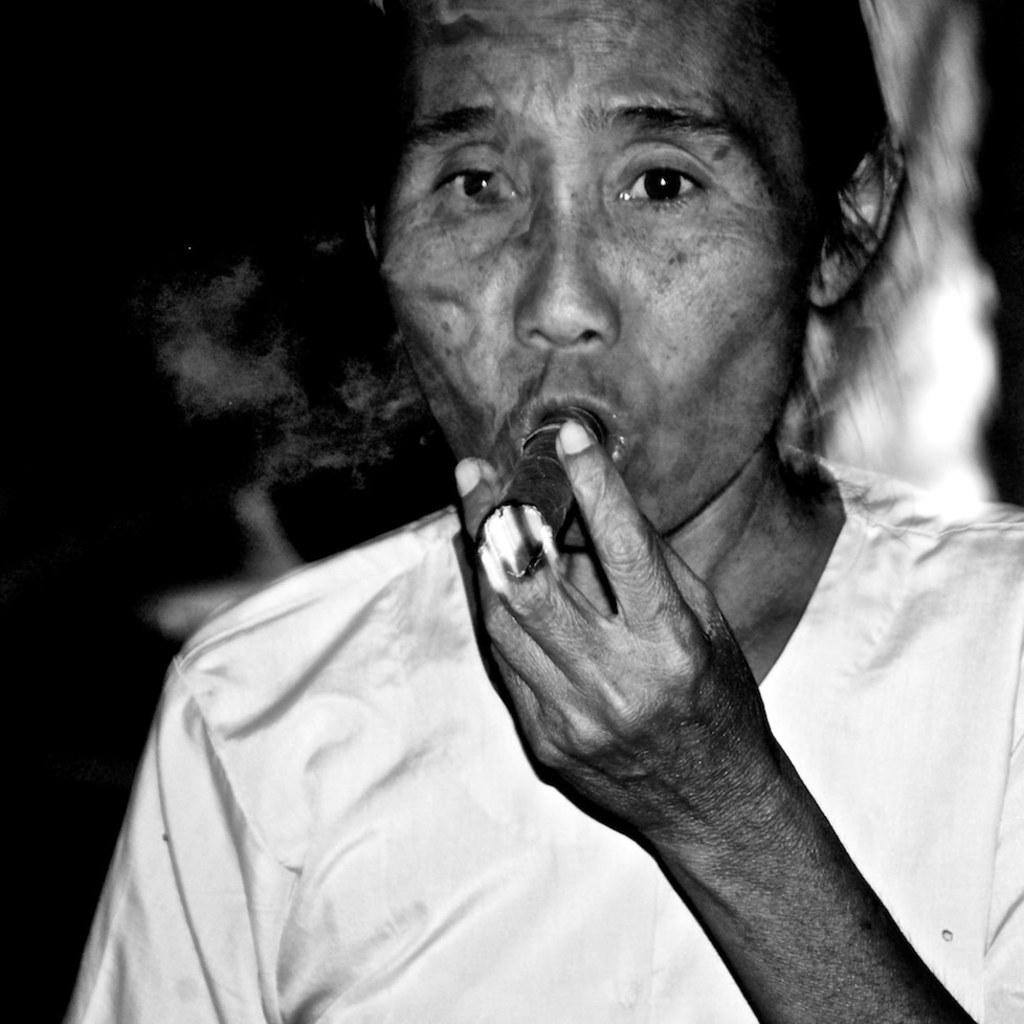What is the color scheme of the image? The image is black and white. Can you describe the person in the image? There is a person in the image, and they are holding a cigar. What can be seen in the background of the image? The background of the image is dark. What type of sign is the fireman holding in the image? There is no fireman or sign present in the image. How many toes can be seen on the person in the image? The image is black and white, and it does not show the person's toes, so it is impossible to determine the number of toes visible. 